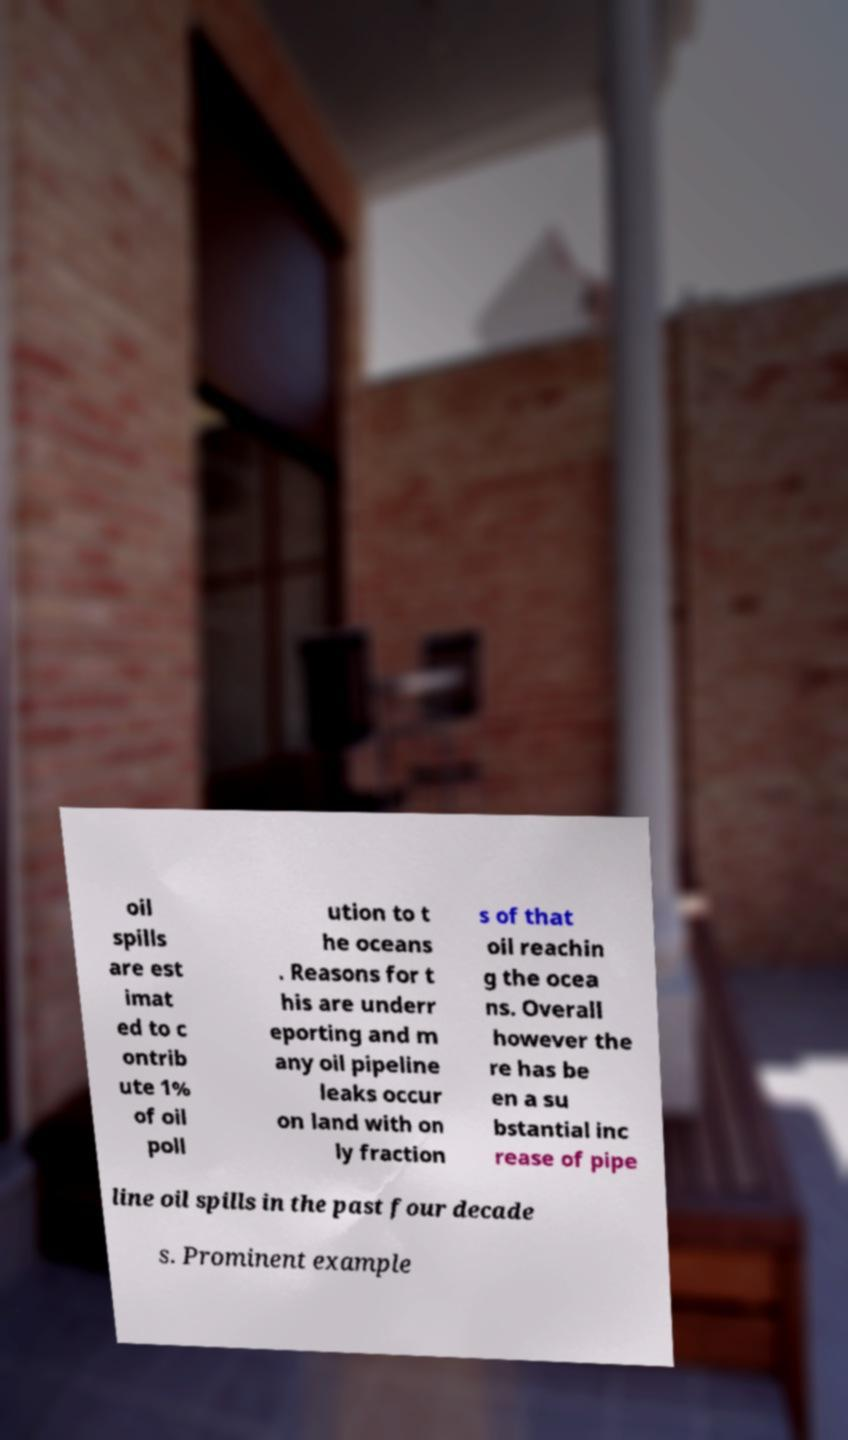Please identify and transcribe the text found in this image. oil spills are est imat ed to c ontrib ute 1% of oil poll ution to t he oceans . Reasons for t his are underr eporting and m any oil pipeline leaks occur on land with on ly fraction s of that oil reachin g the ocea ns. Overall however the re has be en a su bstantial inc rease of pipe line oil spills in the past four decade s. Prominent example 